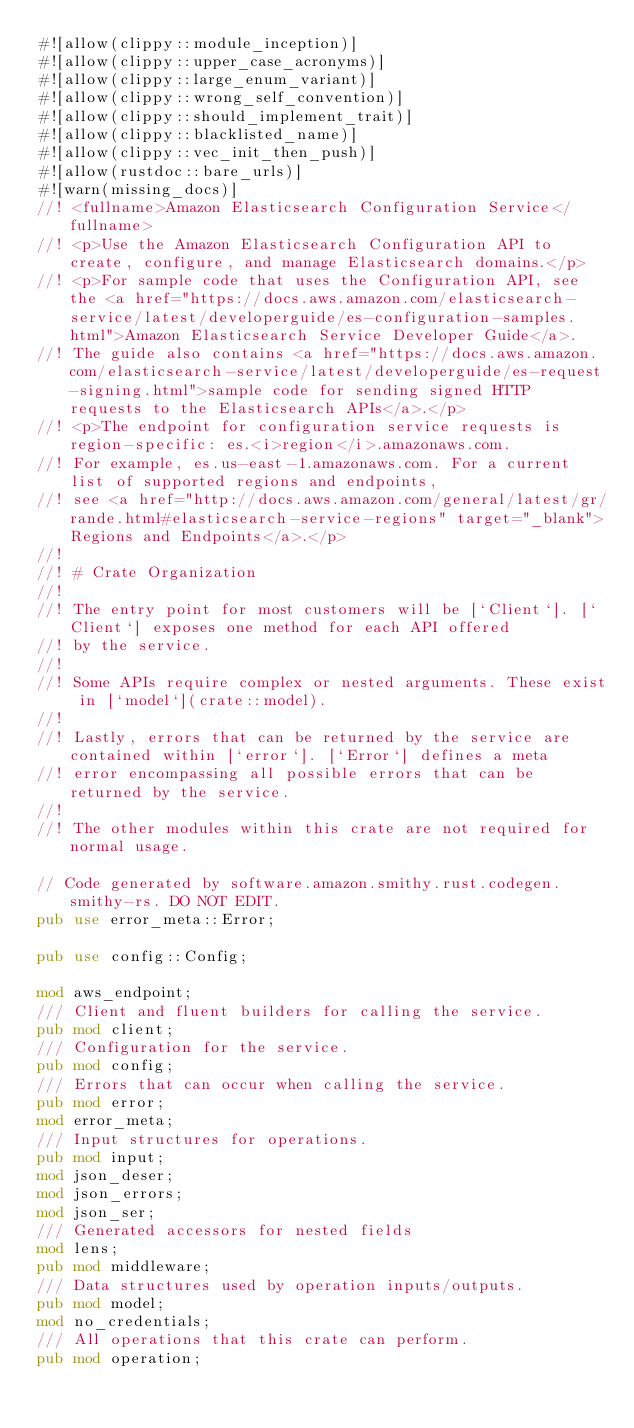<code> <loc_0><loc_0><loc_500><loc_500><_Rust_>#![allow(clippy::module_inception)]
#![allow(clippy::upper_case_acronyms)]
#![allow(clippy::large_enum_variant)]
#![allow(clippy::wrong_self_convention)]
#![allow(clippy::should_implement_trait)]
#![allow(clippy::blacklisted_name)]
#![allow(clippy::vec_init_then_push)]
#![allow(rustdoc::bare_urls)]
#![warn(missing_docs)]
//! <fullname>Amazon Elasticsearch Configuration Service</fullname>
//! <p>Use the Amazon Elasticsearch Configuration API to create, configure, and manage Elasticsearch domains.</p>
//! <p>For sample code that uses the Configuration API, see the <a href="https://docs.aws.amazon.com/elasticsearch-service/latest/developerguide/es-configuration-samples.html">Amazon Elasticsearch Service Developer Guide</a>.
//! The guide also contains <a href="https://docs.aws.amazon.com/elasticsearch-service/latest/developerguide/es-request-signing.html">sample code for sending signed HTTP requests to the Elasticsearch APIs</a>.</p>
//! <p>The endpoint for configuration service requests is region-specific: es.<i>region</i>.amazonaws.com.
//! For example, es.us-east-1.amazonaws.com. For a current list of supported regions and endpoints,
//! see <a href="http://docs.aws.amazon.com/general/latest/gr/rande.html#elasticsearch-service-regions" target="_blank">Regions and Endpoints</a>.</p>
//!
//! # Crate Organization
//!
//! The entry point for most customers will be [`Client`]. [`Client`] exposes one method for each API offered
//! by the service.
//!
//! Some APIs require complex or nested arguments. These exist in [`model`](crate::model).
//!
//! Lastly, errors that can be returned by the service are contained within [`error`]. [`Error`] defines a meta
//! error encompassing all possible errors that can be returned by the service.
//!
//! The other modules within this crate are not required for normal usage.

// Code generated by software.amazon.smithy.rust.codegen.smithy-rs. DO NOT EDIT.
pub use error_meta::Error;

pub use config::Config;

mod aws_endpoint;
/// Client and fluent builders for calling the service.
pub mod client;
/// Configuration for the service.
pub mod config;
/// Errors that can occur when calling the service.
pub mod error;
mod error_meta;
/// Input structures for operations.
pub mod input;
mod json_deser;
mod json_errors;
mod json_ser;
/// Generated accessors for nested fields
mod lens;
pub mod middleware;
/// Data structures used by operation inputs/outputs.
pub mod model;
mod no_credentials;
/// All operations that this crate can perform.
pub mod operation;</code> 